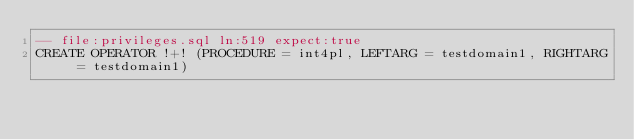<code> <loc_0><loc_0><loc_500><loc_500><_SQL_>-- file:privileges.sql ln:519 expect:true
CREATE OPERATOR !+! (PROCEDURE = int4pl, LEFTARG = testdomain1, RIGHTARG = testdomain1)
</code> 